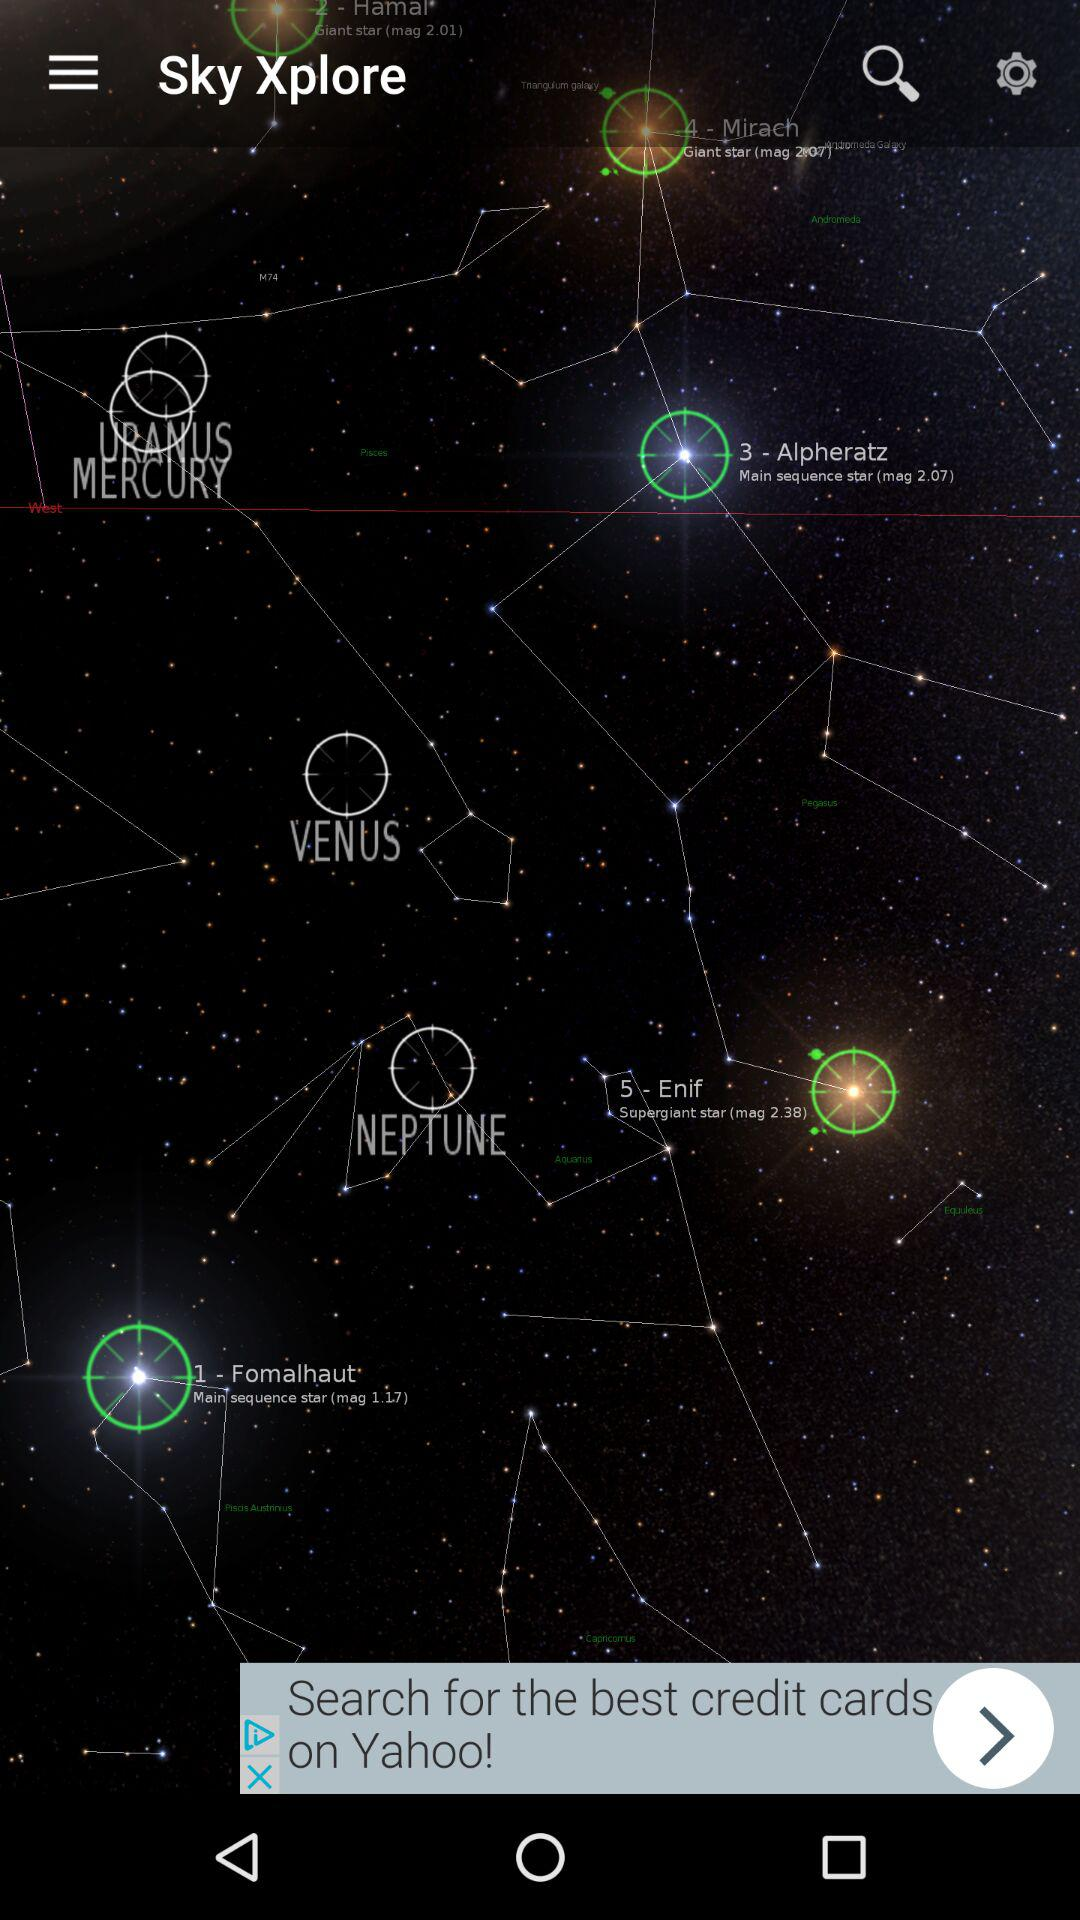What is the app name? The app name is "Sky Xplore". 